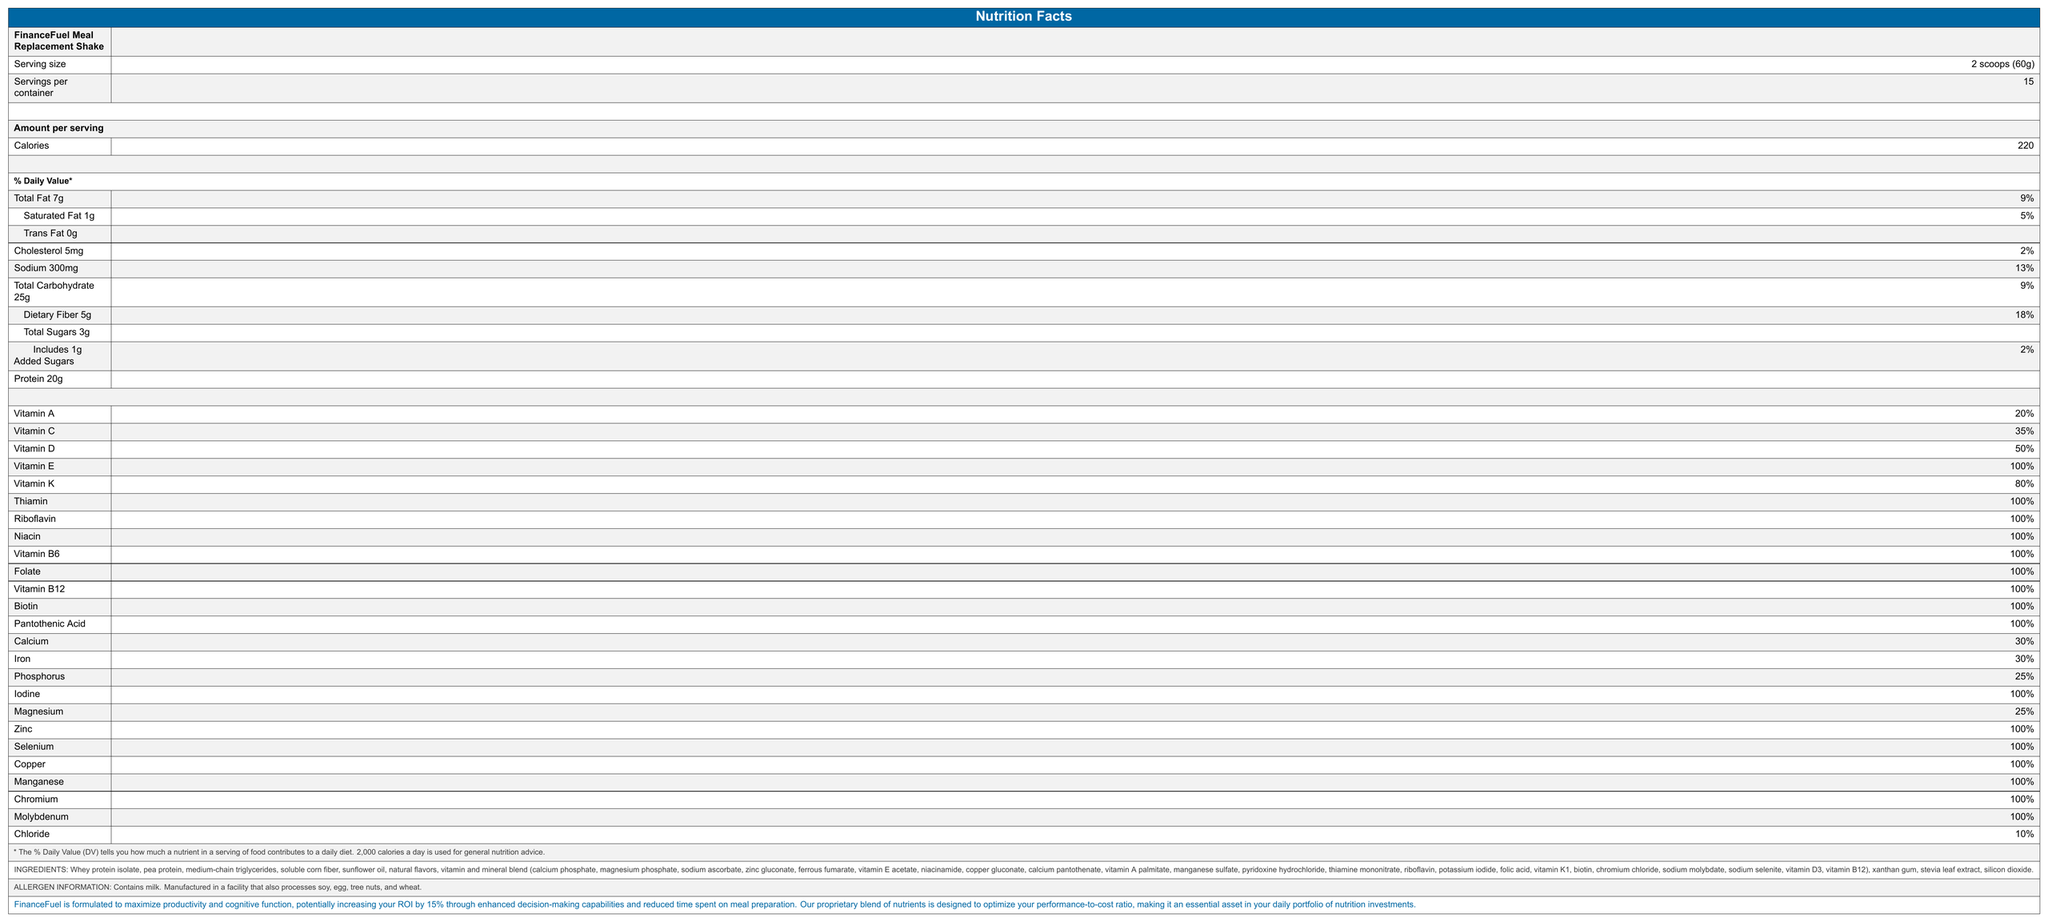what is the serving size of FinanceFuel Meal Replacement Shake? The document specifies that the serving size for the meal replacement shake is 2 scoops, which amount to 60 grams.
Answer: 2 scoops (60g) how many calories are in one serving? The document states that each serving contains 220 calories.
Answer: 220 what percentage of the daily value of protein does one serving provide? The document lists the amount of protein as 20g but does not specify the daily value percentage.
Answer: Not Specified what allergens are present in the product? The allergen information section states that the product contains milk.
Answer: Milk how many servings are in one container? The document specifies that there are 15 servings per container.
Answer: 15 what is the amount of dietary fiber in one serving? The document mentions that one serving includes 5g of dietary fiber.
Answer: 5g what is the percentage of the daily value for Vitamin C in each serving? According to the document, each serving provides 35% of the daily value for Vitamin C.
Answer: 35% how much sodium does one serving contain? The document states that one serving contains 300mg of sodium.
Answer: 300mg how many grams of total sugars are in one serving? The document indicates that one serving includes 3g of total sugars.
Answer: 3g what is the listed percentage of daily value for saturated fat? The document lists the percentage of daily value for saturated fat as 5%.
Answer: 5% which vitamin has the highest daily value percentage in a single serving? a) Vitamin A b) Vitamin C c) Vitamin E d) Vitamin D The document shows that Vitamin E has a daily value percentage of 100%, the highest among the listed vitamins.
Answer: c) Vitamin E how much cholesterol is in one serving? a) 2mg b) 5mg c) 10mg d) 15mg The document specifies that there are 5mg of cholesterol in one serving.
Answer: b) 5mg is the FinanceFuel Meal Replacement Shake designed to maximize productivity? The financial performance statement section claims that the product is formulated to maximize productivity and cognitive function.
Answer: Yes summarize the key nutritional and functional features of FinanceFuel Meal Replacement Shake. The summary includes the major nutritional details such as calorie content, macronutrient breakdown, and high percentages of vitamins and minerals. It also mentions the functional benefit claimed in the document.
Answer: The FinanceFuel Meal Replacement Shake provides comprehensive nutrition, offering 220 calories and a balanced amount of macronutrients. It contains 7g of total fat, 25g of total carbohydrates, 5g of dietary fiber, and 20g of protein per serving. The product is rich in vitamins and minerals, with many reaching 100% of the daily value. It is marketed as a way to enhance productivity and cognitive function, potentially increasing ROI by 15%. does the product contain artificial sweeteners? The document lists natural flavors and stevia leaf extract but does not clearly differentiate if any artificial sweeteners are present.
Answer: Not enough information 